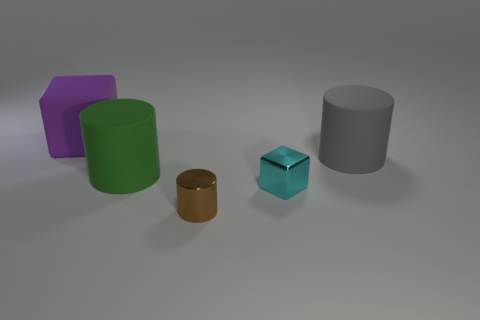Is there a small cyan sphere made of the same material as the green cylinder?
Provide a succinct answer. No. What is the material of the gray thing that is the same size as the purple rubber thing?
Your response must be concise. Rubber. There is a big cylinder that is to the right of the green cylinder; is its color the same as the object behind the gray cylinder?
Ensure brevity in your answer.  No. There is a tiny metal object in front of the tiny cube; is there a cyan metallic object in front of it?
Offer a very short reply. No. Is the shape of the big matte thing that is behind the gray thing the same as the small shiny thing in front of the small cyan thing?
Offer a terse response. No. Does the big cylinder to the left of the tiny brown thing have the same material as the small thing that is behind the tiny metal cylinder?
Provide a succinct answer. No. What material is the thing that is behind the cylinder behind the large green rubber object made of?
Give a very brief answer. Rubber. What is the shape of the large matte thing that is to the right of the shiny object on the left side of the cube in front of the big block?
Keep it short and to the point. Cylinder. There is a tiny thing that is the same shape as the large purple rubber thing; what is it made of?
Provide a succinct answer. Metal. What number of small blue matte blocks are there?
Keep it short and to the point. 0. 